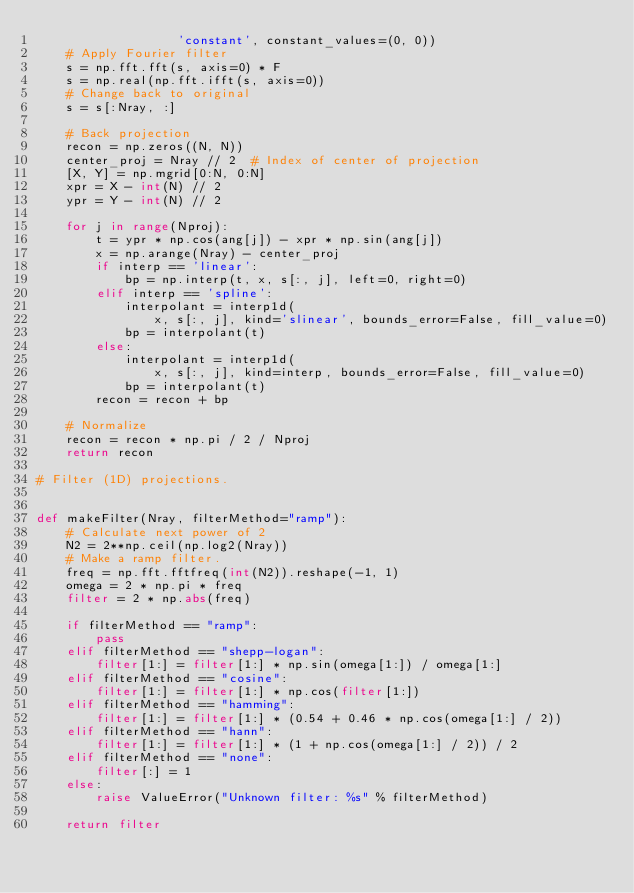<code> <loc_0><loc_0><loc_500><loc_500><_Python_>                   'constant', constant_values=(0, 0))
    # Apply Fourier filter
    s = np.fft.fft(s, axis=0) * F
    s = np.real(np.fft.ifft(s, axis=0))
    # Change back to original
    s = s[:Nray, :]

    # Back projection
    recon = np.zeros((N, N))
    center_proj = Nray // 2  # Index of center of projection
    [X, Y] = np.mgrid[0:N, 0:N]
    xpr = X - int(N) // 2
    ypr = Y - int(N) // 2

    for j in range(Nproj):
        t = ypr * np.cos(ang[j]) - xpr * np.sin(ang[j])
        x = np.arange(Nray) - center_proj
        if interp == 'linear':
            bp = np.interp(t, x, s[:, j], left=0, right=0)
        elif interp == 'spline':
            interpolant = interp1d(
                x, s[:, j], kind='slinear', bounds_error=False, fill_value=0)
            bp = interpolant(t)
        else:
            interpolant = interp1d(
                x, s[:, j], kind=interp, bounds_error=False, fill_value=0)
            bp = interpolant(t)
        recon = recon + bp

    # Normalize
    recon = recon * np.pi / 2 / Nproj
    return recon

# Filter (1D) projections.


def makeFilter(Nray, filterMethod="ramp"):
    # Calculate next power of 2
    N2 = 2**np.ceil(np.log2(Nray))
    # Make a ramp filter.
    freq = np.fft.fftfreq(int(N2)).reshape(-1, 1)
    omega = 2 * np.pi * freq
    filter = 2 * np.abs(freq)

    if filterMethod == "ramp":
        pass
    elif filterMethod == "shepp-logan":
        filter[1:] = filter[1:] * np.sin(omega[1:]) / omega[1:]
    elif filterMethod == "cosine":
        filter[1:] = filter[1:] * np.cos(filter[1:])
    elif filterMethod == "hamming":
        filter[1:] = filter[1:] * (0.54 + 0.46 * np.cos(omega[1:] / 2))
    elif filterMethod == "hann":
        filter[1:] = filter[1:] * (1 + np.cos(omega[1:] / 2)) / 2
    elif filterMethod == "none":
        filter[:] = 1
    else:
        raise ValueError("Unknown filter: %s" % filterMethod)

    return filter
</code> 